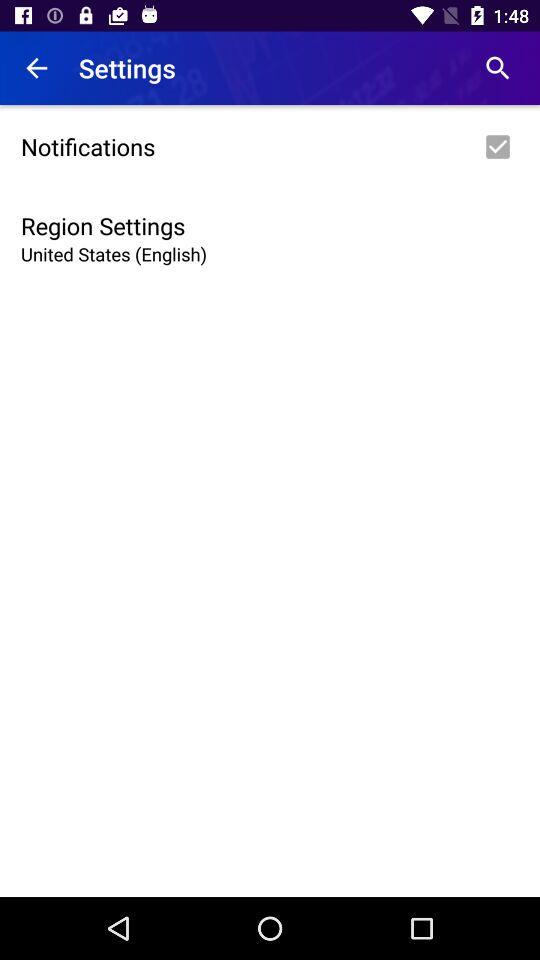Which region is selected? The selected region is the United States. 